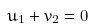Convert formula to latex. <formula><loc_0><loc_0><loc_500><loc_500>u _ { 1 } + v _ { 2 } = 0</formula> 